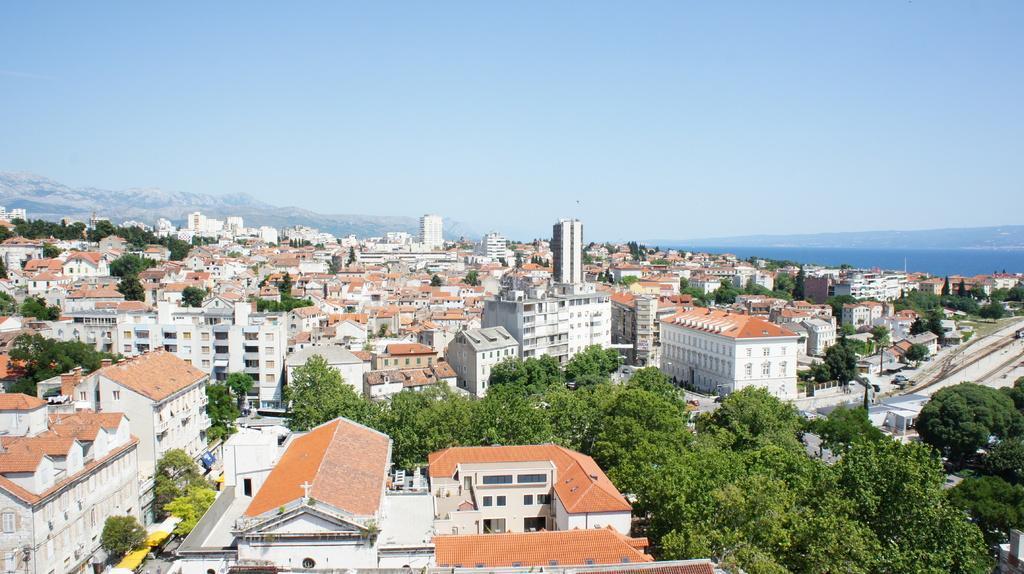Could you give a brief overview of what you see in this image? In this image I can see many buildings and trees. To the right I can see the poles and the train on the track. In the background I can see the mountains and the sky. 